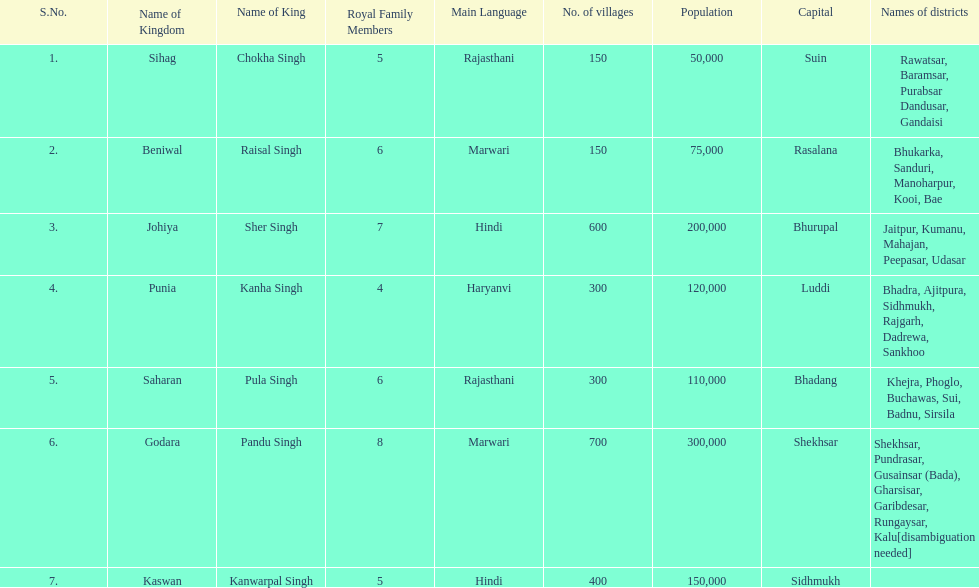Which kingdom has the most villages? Godara. 